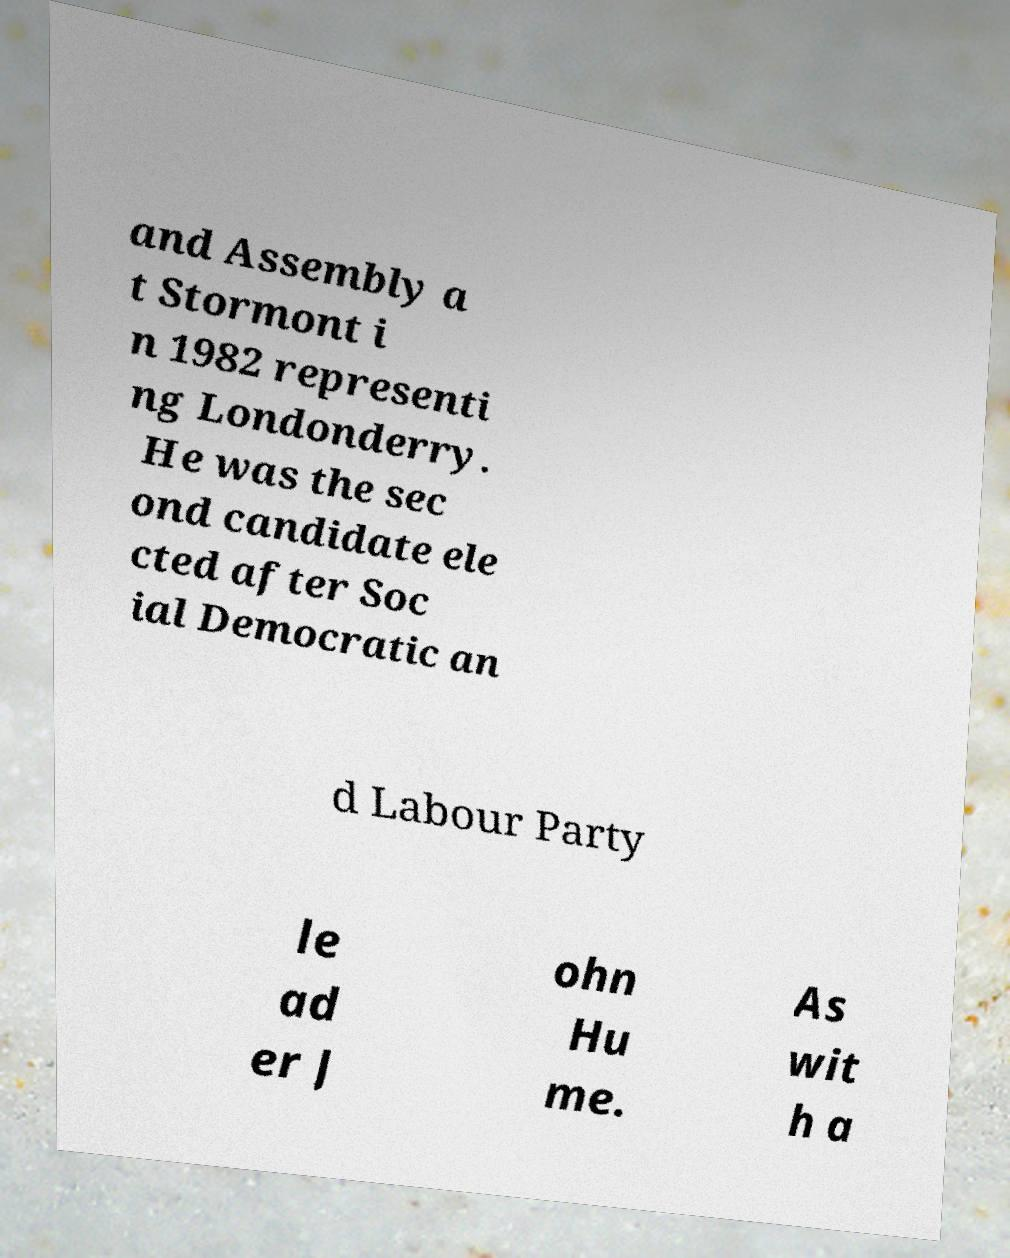There's text embedded in this image that I need extracted. Can you transcribe it verbatim? and Assembly a t Stormont i n 1982 representi ng Londonderry. He was the sec ond candidate ele cted after Soc ial Democratic an d Labour Party le ad er J ohn Hu me. As wit h a 